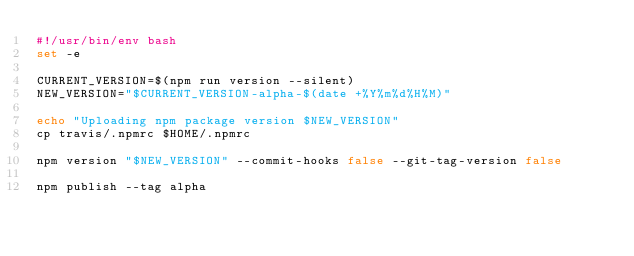Convert code to text. <code><loc_0><loc_0><loc_500><loc_500><_Bash_>#!/usr/bin/env bash
set -e

CURRENT_VERSION=$(npm run version --silent)
NEW_VERSION="$CURRENT_VERSION-alpha-$(date +%Y%m%d%H%M)"

echo "Uploading npm package version $NEW_VERSION"
cp travis/.npmrc $HOME/.npmrc

npm version "$NEW_VERSION" --commit-hooks false --git-tag-version false

npm publish --tag alpha
</code> 